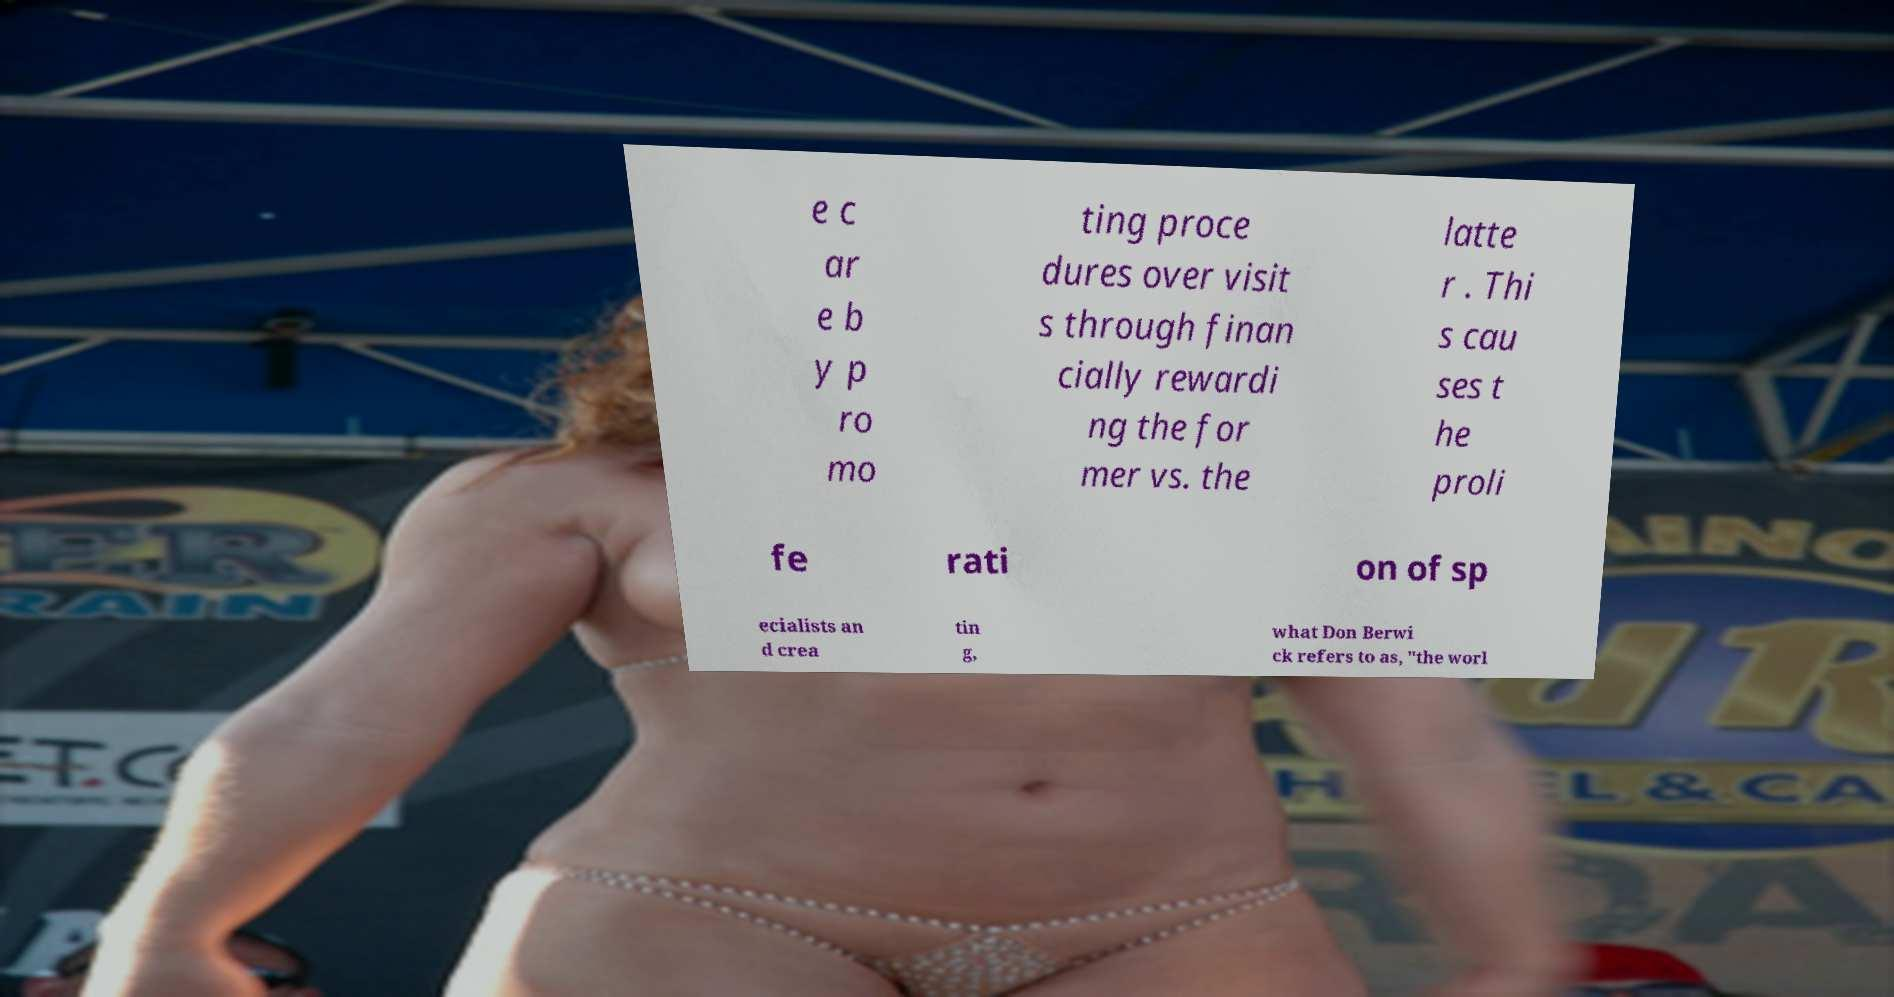Please identify and transcribe the text found in this image. e c ar e b y p ro mo ting proce dures over visit s through finan cially rewardi ng the for mer vs. the latte r . Thi s cau ses t he proli fe rati on of sp ecialists an d crea tin g, what Don Berwi ck refers to as, "the worl 